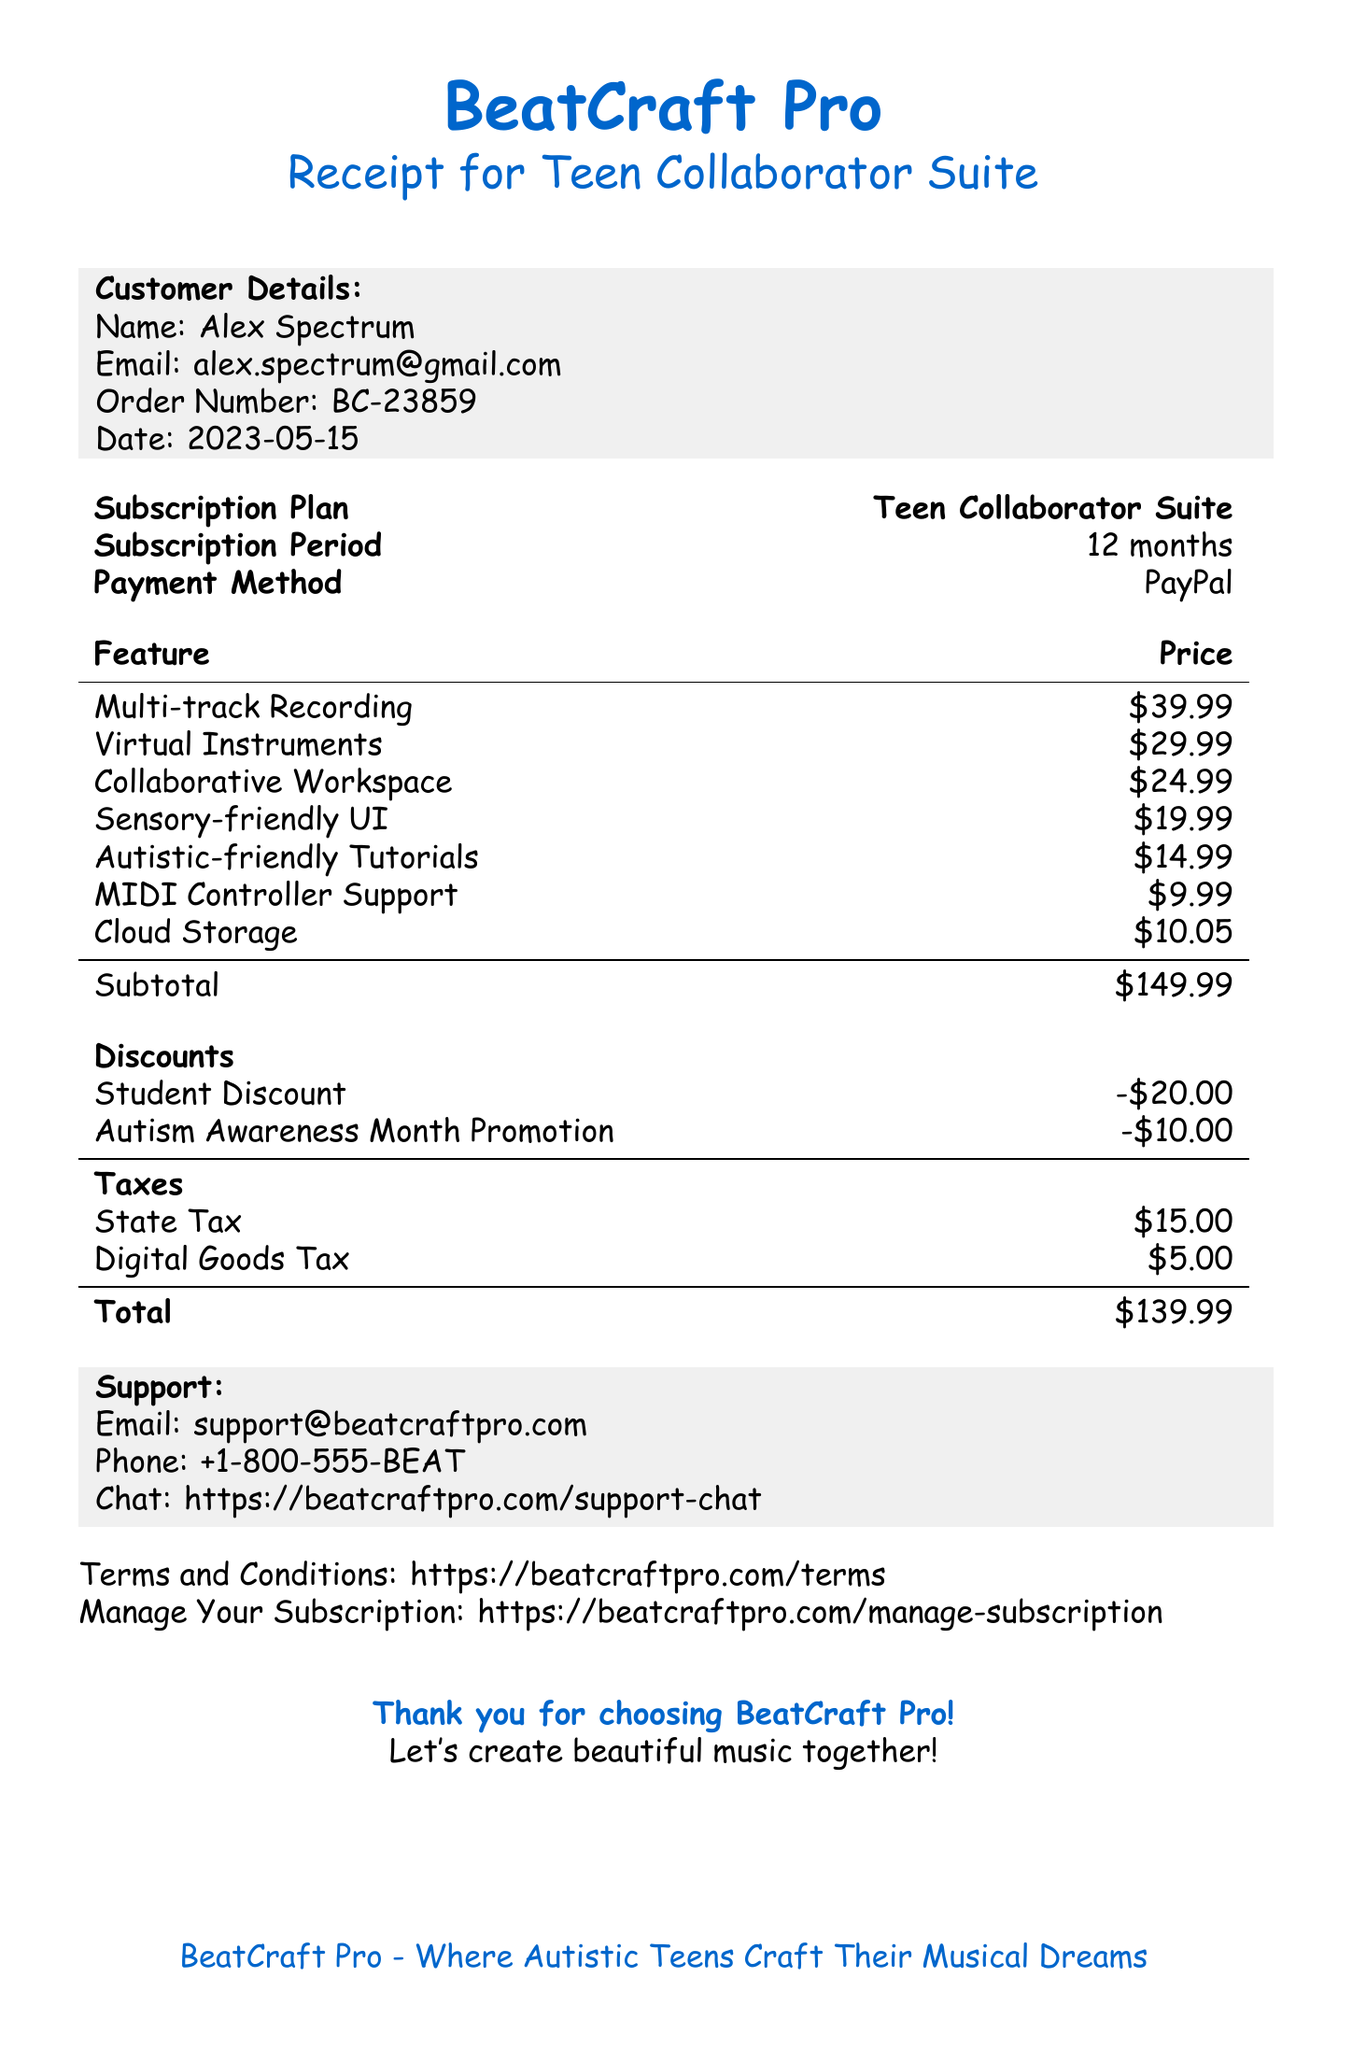What is the subscription plan? The subscription plan is highlighted in the document and is "Teen Collaborator Suite."
Answer: Teen Collaborator Suite What is the total amount paid? The total amount is specified in the document as "$149.99."
Answer: $149.99 What discount is applied for being a student? The document indicates a discount amount for students as "-$20.00."
Answer: -$20.00 What is the customer's email address? The email address of the customer is provided in the document as "alex.spectrum@gmail.com."
Answer: alex.spectrum@gmail.com How many tracks can be recorded simultaneously? The feature of multi-track recording allows for up to 64 tracks to be recorded at once, as stated in the document.
Answer: 64 tracks What is the purpose of the "Sensory-friendly UI"? The document describes the "Sensory-friendly UI" as a customizable interface for visual comfort.
Answer: Visual comfort How many musicians can collaborate in the workspace? According to the document, the collaborative workspace supports real-time collaboration with up to 5 musicians.
Answer: 5 musicians What method of payment was used? The method of payment is clearly indicated in the document as "PayPal."
Answer: PayPal What are the support contact details? The support contact details include an email, phone, and chat link, all specified in the document.
Answer: support@beatcraftpro.com, +1-800-555-BEAT, https://beatcraftpro.com/support-chat 